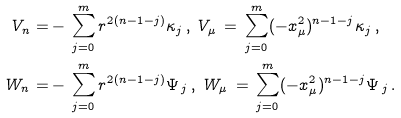Convert formula to latex. <formula><loc_0><loc_0><loc_500><loc_500>V _ { n } = & - \, \sum _ { j = 0 } ^ { m } r ^ { 2 ( n - 1 - j ) } \kappa _ { j } \, , \ V _ { \mu } \, = \, \sum _ { j = 0 } ^ { m } ( - x _ { \mu } ^ { 2 } ) ^ { n - 1 - j } \kappa _ { j } \, , \\ W _ { n } = & - \, \sum _ { j = 0 } ^ { m } r ^ { 2 ( n - 1 - j ) } \Psi _ { \, j } \, , \ W _ { \mu } \, = \, \sum _ { j = 0 } ^ { m } ( - x _ { \mu } ^ { 2 } ) ^ { n - 1 - j } \Psi _ { \, j } \, .</formula> 